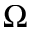<formula> <loc_0><loc_0><loc_500><loc_500>\Omega</formula> 